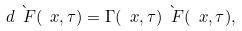Convert formula to latex. <formula><loc_0><loc_0><loc_500><loc_500>d \grave { \ F } ( \ x , \tau ) = \Gamma ( \ x , \tau ) \grave { \ F } ( \ x , \tau ) ,</formula> 